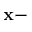Convert formula to latex. <formula><loc_0><loc_0><loc_500><loc_500>x -</formula> 